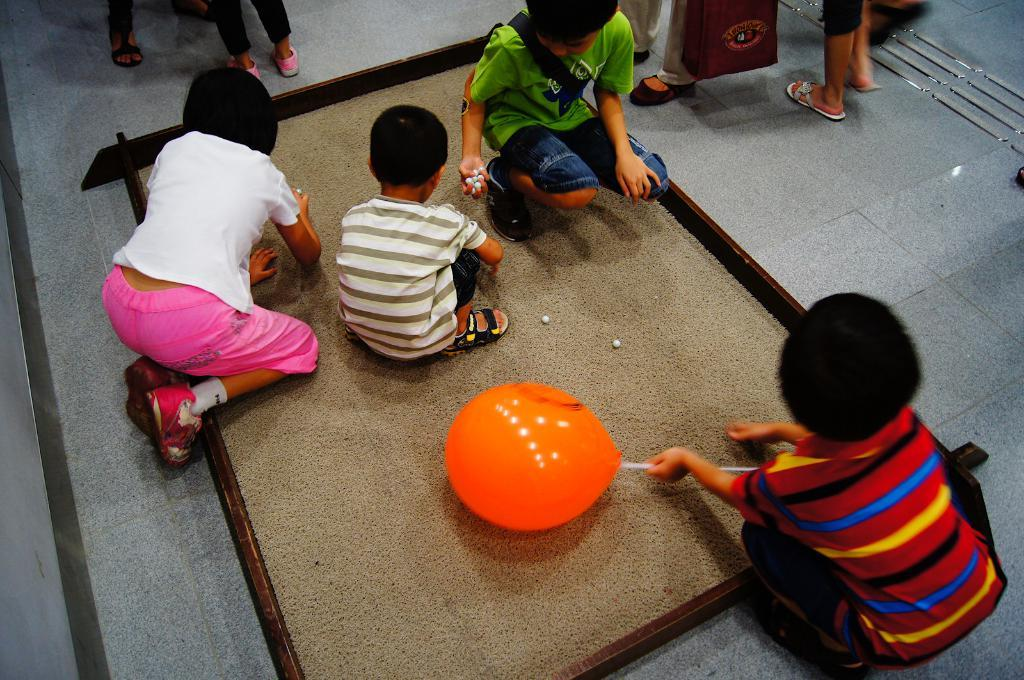How many children are present in the image? There are multiple children in the image. What object is one of the children holding? One of the children is holding a balloon. What activity are the children engaged in? The children are playing. What type of fan can be seen in the image? There is no fan present in the image. How many blades does the plane have in the image? There is no plane present in the image, so it is not possible to determine the number of blades. 